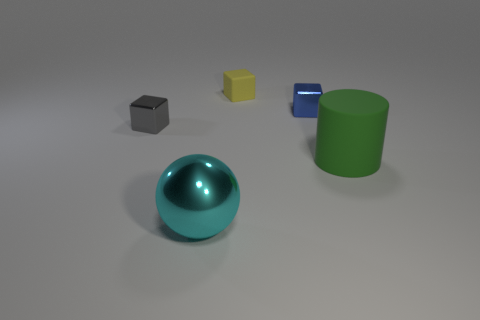Which object seems to be in the foreground and what might that indicate? The teal spherical object appears to be in the foreground, as it is larger and more central than the other items. This positioning may indicate that it's meant to be the focal point of the image, drawing the viewer's attention and potentially signifying its importance or relevance above the other objects. Its placement could also be part of an exercise in perspective, emphasizing depth and dimension in composition. 